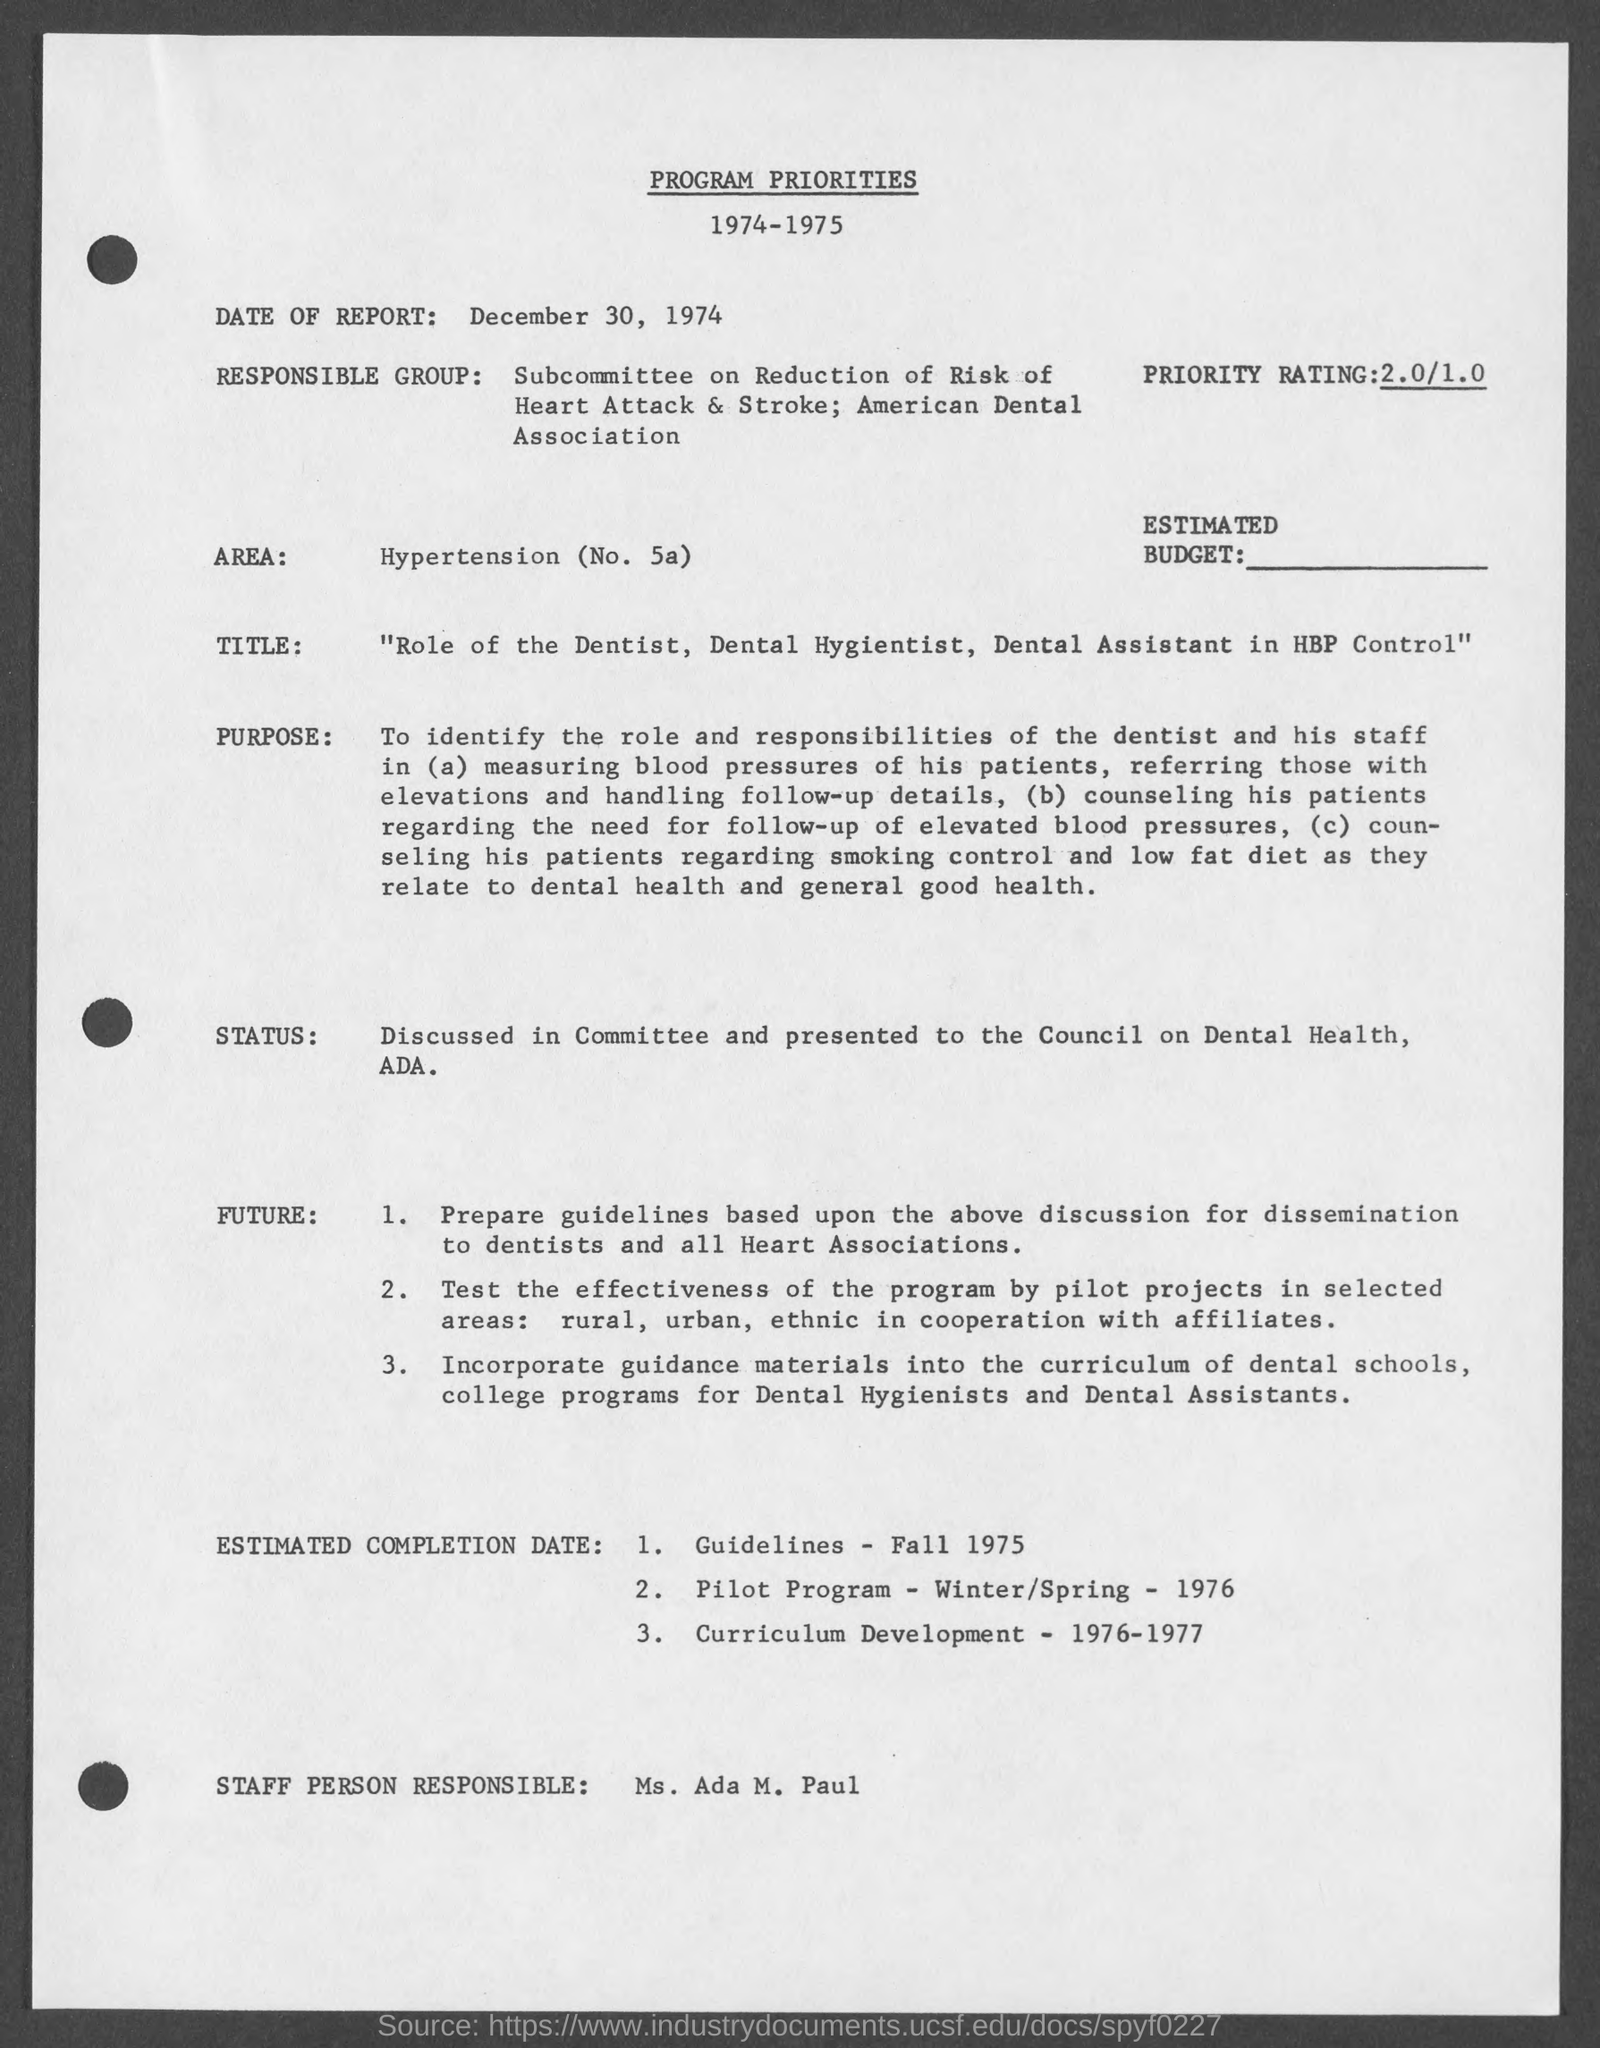What is the date of report ?
Provide a succinct answer. December 30, 1974. Who is the staff person responsible?
Your response must be concise. Ms. Ada M. Paul. 